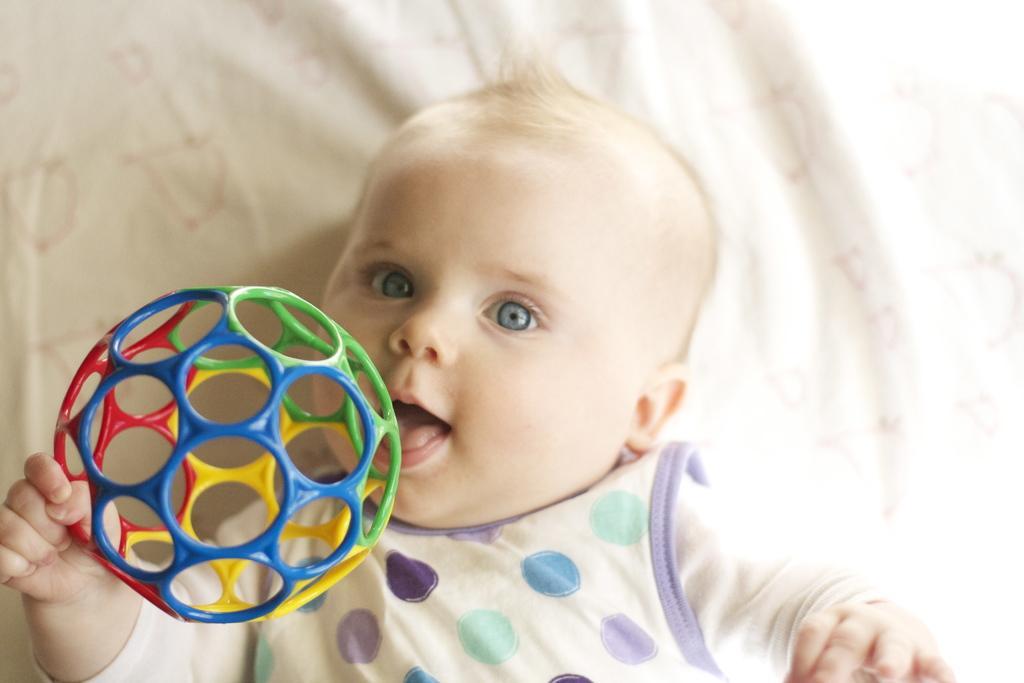Please provide a concise description of this image. In this picture we can see a baby lying on a cloth and holding a toy with hand. 